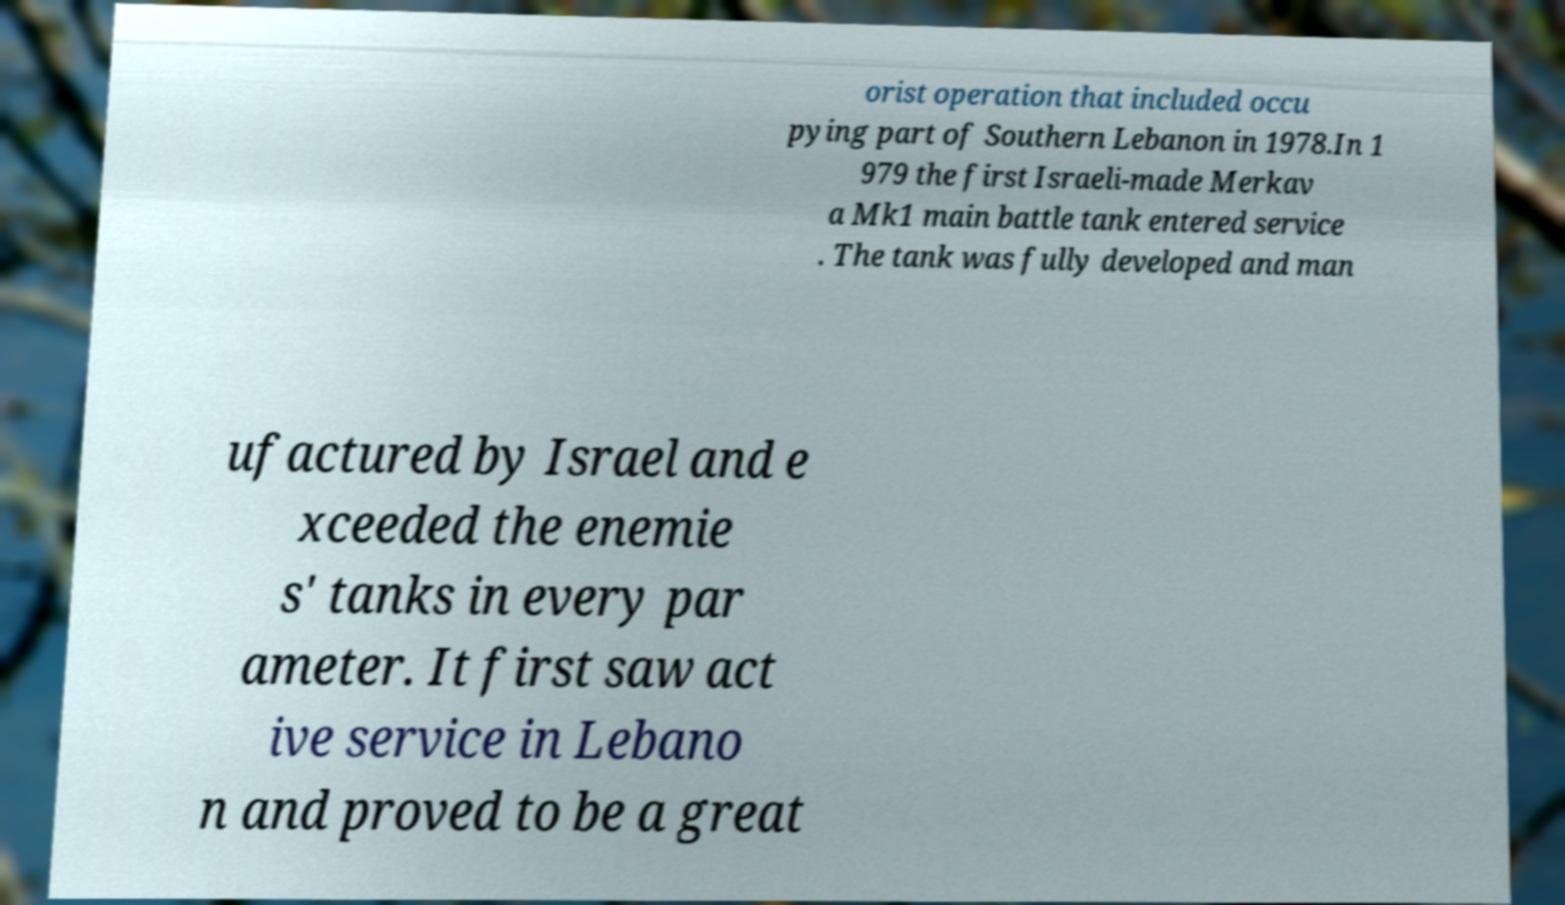Could you assist in decoding the text presented in this image and type it out clearly? orist operation that included occu pying part of Southern Lebanon in 1978.In 1 979 the first Israeli-made Merkav a Mk1 main battle tank entered service . The tank was fully developed and man ufactured by Israel and e xceeded the enemie s' tanks in every par ameter. It first saw act ive service in Lebano n and proved to be a great 